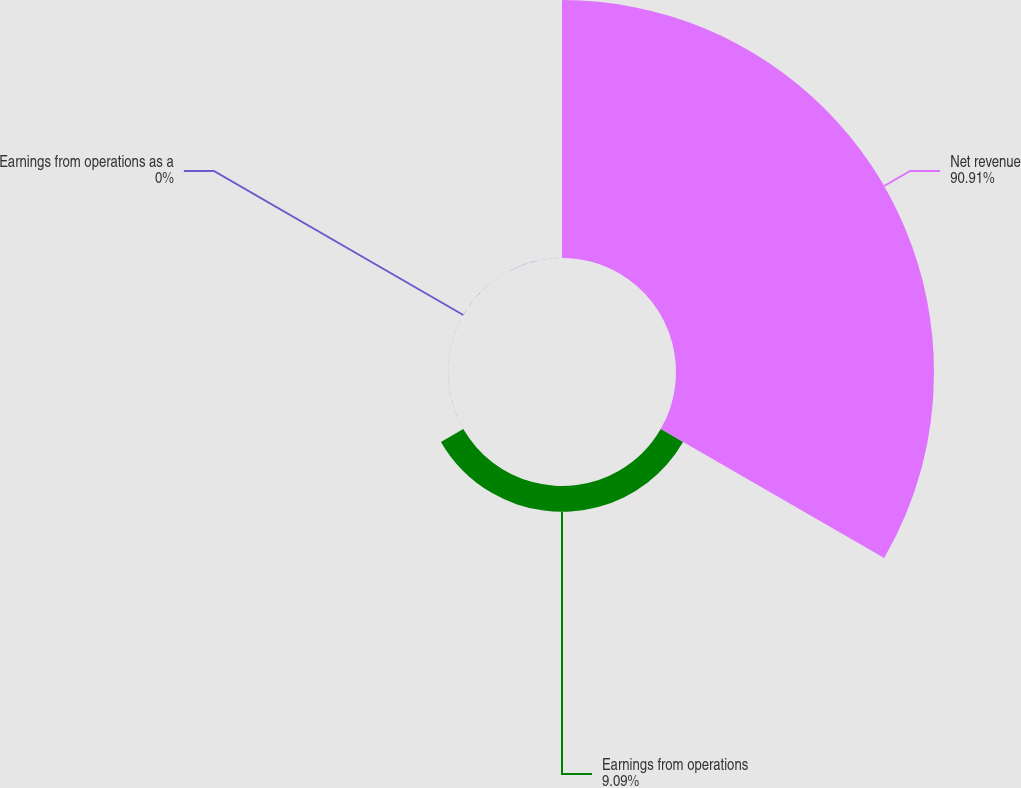Convert chart to OTSL. <chart><loc_0><loc_0><loc_500><loc_500><pie_chart><fcel>Net revenue<fcel>Earnings from operations<fcel>Earnings from operations as a<nl><fcel>90.9%<fcel>9.09%<fcel>0.0%<nl></chart> 